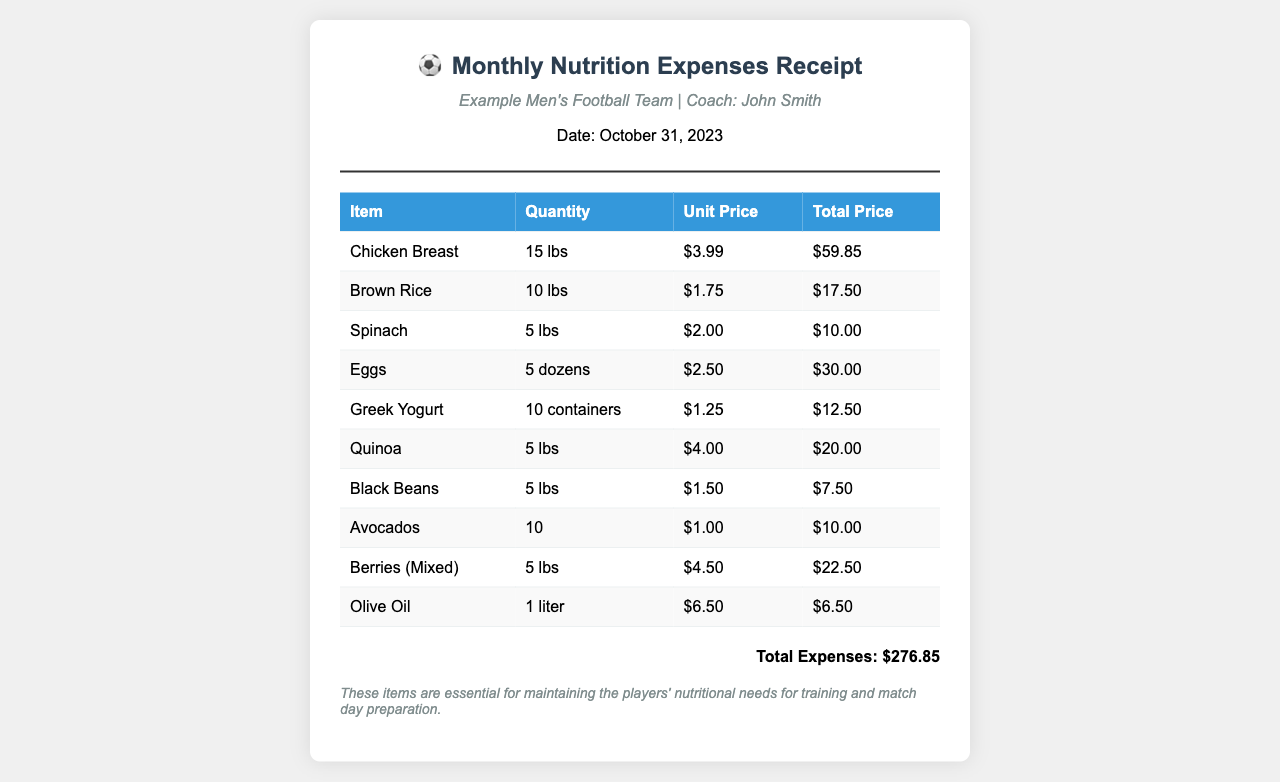What is the date of the receipt? The date is mentioned in the header of the receipt, which is October 31, 2023.
Answer: October 31, 2023 Who is the coach of the football team? The coach's name is provided in the team information section of the receipt, which states "Coach: John Smith."
Answer: John Smith What is the total expenses amount? The total expenses are calculated and presented at the bottom of the receipt as "$276.85."
Answer: $276.85 How many pounds of chicken breast were purchased? The quantity of chicken breast is listed in the item table as "15 lbs."
Answer: 15 lbs What item costs $4.50 per pound? The item table lists "Berries (Mixed)" with a unit price of "$4.50."
Answer: Berries (Mixed) What is the quantity of eggs purchased? The quantity of eggs is specified in the item table as "5 dozens."
Answer: 5 dozens What essential dietary item is associated with maintaining players' nutritional needs? The notes section indicates that the items are essential for "maintaining the players' nutritional needs."
Answer: Essential items How much did the olive oil cost? The unit price for olive oil is stated in the item table as "$6.50."
Answer: $6.50 Which item has the lowest total price? In the item list, "Olive Oil" has the lowest total price of "$6.50."
Answer: Olive Oil 